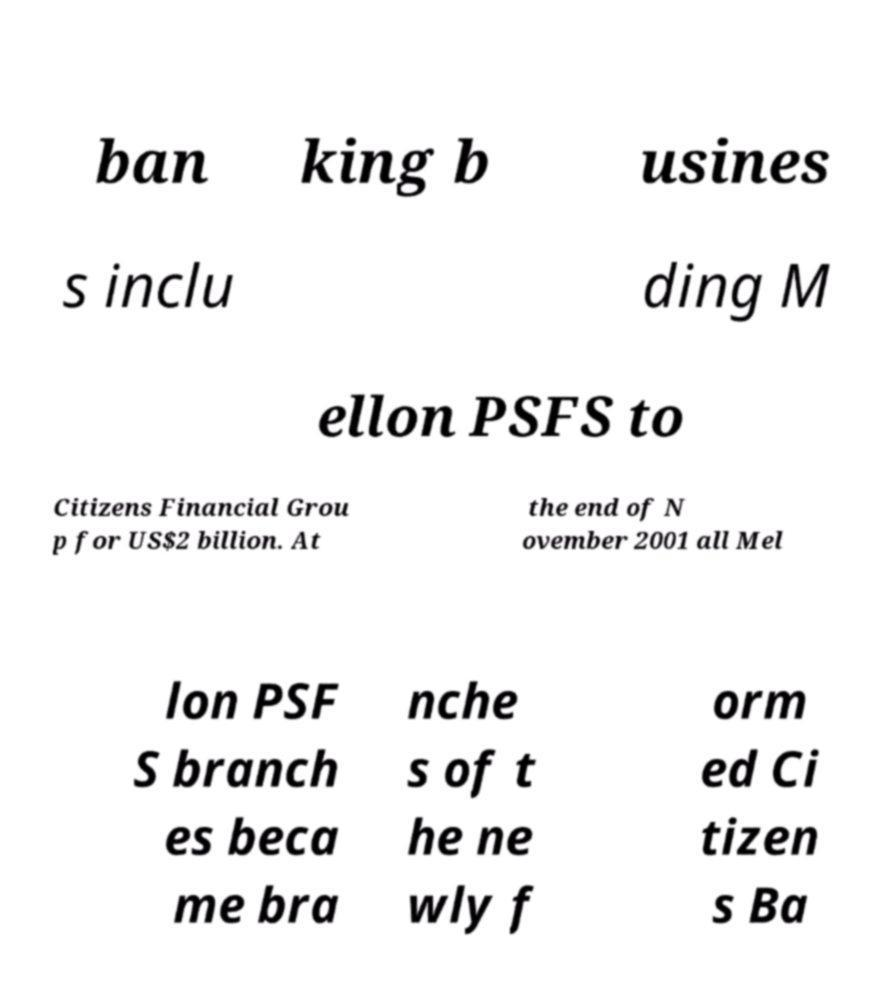Can you read and provide the text displayed in the image?This photo seems to have some interesting text. Can you extract and type it out for me? ban king b usines s inclu ding M ellon PSFS to Citizens Financial Grou p for US$2 billion. At the end of N ovember 2001 all Mel lon PSF S branch es beca me bra nche s of t he ne wly f orm ed Ci tizen s Ba 